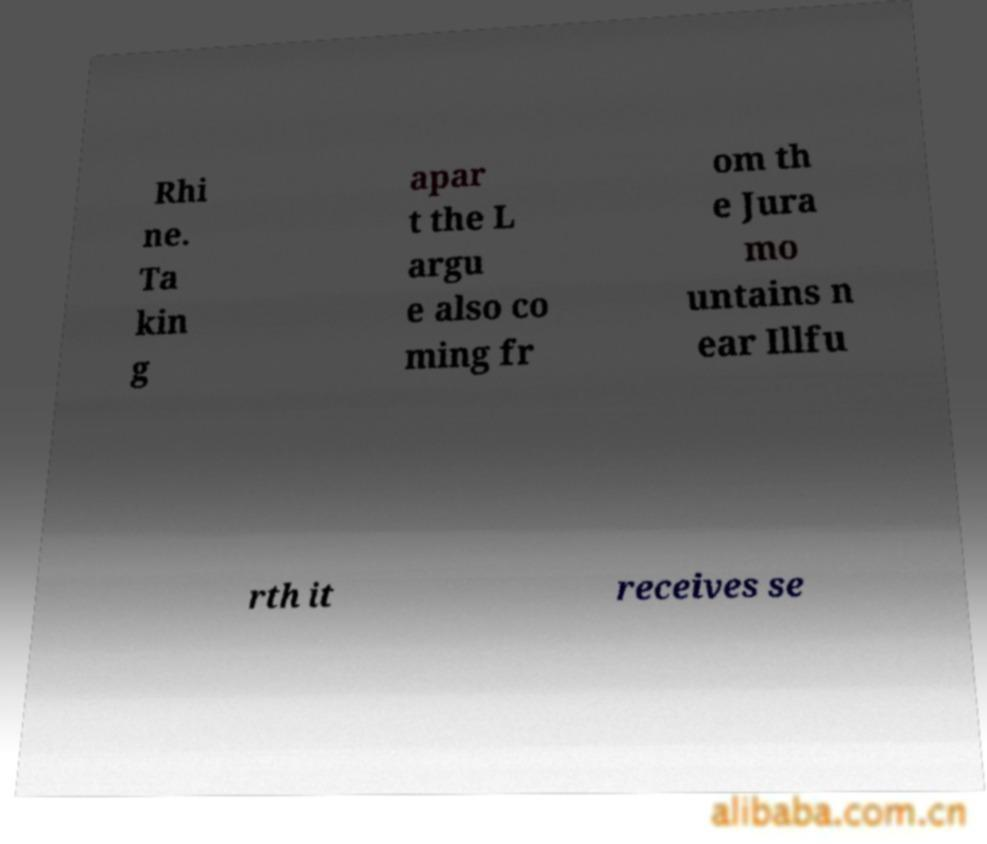Please read and relay the text visible in this image. What does it say? Rhi ne. Ta kin g apar t the L argu e also co ming fr om th e Jura mo untains n ear Illfu rth it receives se 